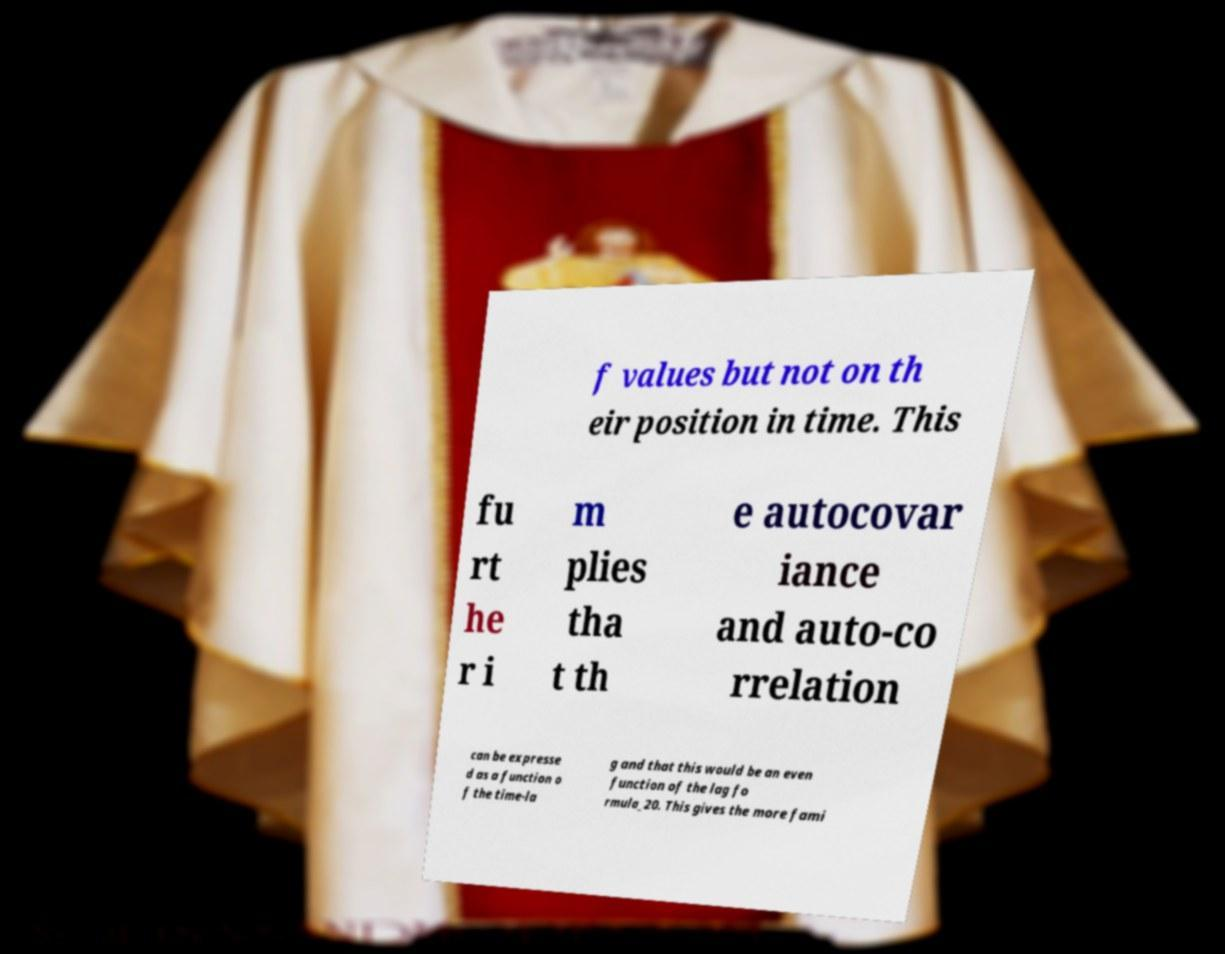There's text embedded in this image that I need extracted. Can you transcribe it verbatim? f values but not on th eir position in time. This fu rt he r i m plies tha t th e autocovar iance and auto-co rrelation can be expresse d as a function o f the time-la g and that this would be an even function of the lag fo rmula_20. This gives the more fami 